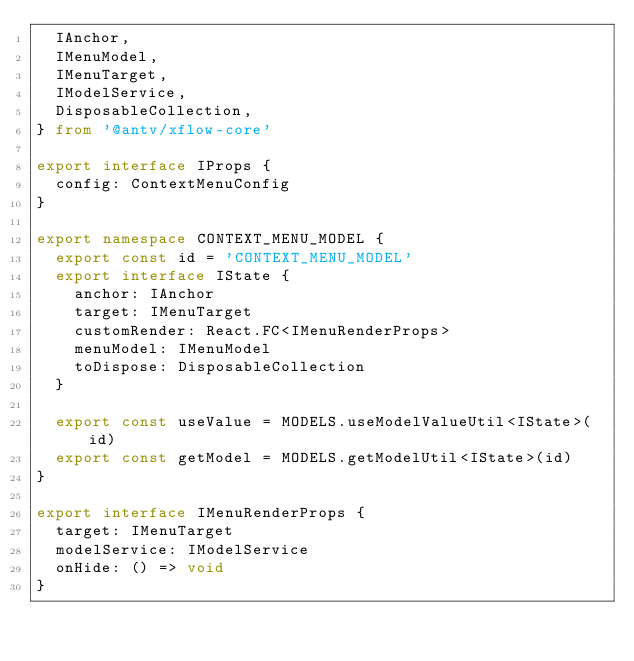<code> <loc_0><loc_0><loc_500><loc_500><_TypeScript_>  IAnchor,
  IMenuModel,
  IMenuTarget,
  IModelService,
  DisposableCollection,
} from '@antv/xflow-core'

export interface IProps {
  config: ContextMenuConfig
}

export namespace CONTEXT_MENU_MODEL {
  export const id = 'CONTEXT_MENU_MODEL'
  export interface IState {
    anchor: IAnchor
    target: IMenuTarget
    customRender: React.FC<IMenuRenderProps>
    menuModel: IMenuModel
    toDispose: DisposableCollection
  }

  export const useValue = MODELS.useModelValueUtil<IState>(id)
  export const getModel = MODELS.getModelUtil<IState>(id)
}

export interface IMenuRenderProps {
  target: IMenuTarget
  modelService: IModelService
  onHide: () => void
}
</code> 